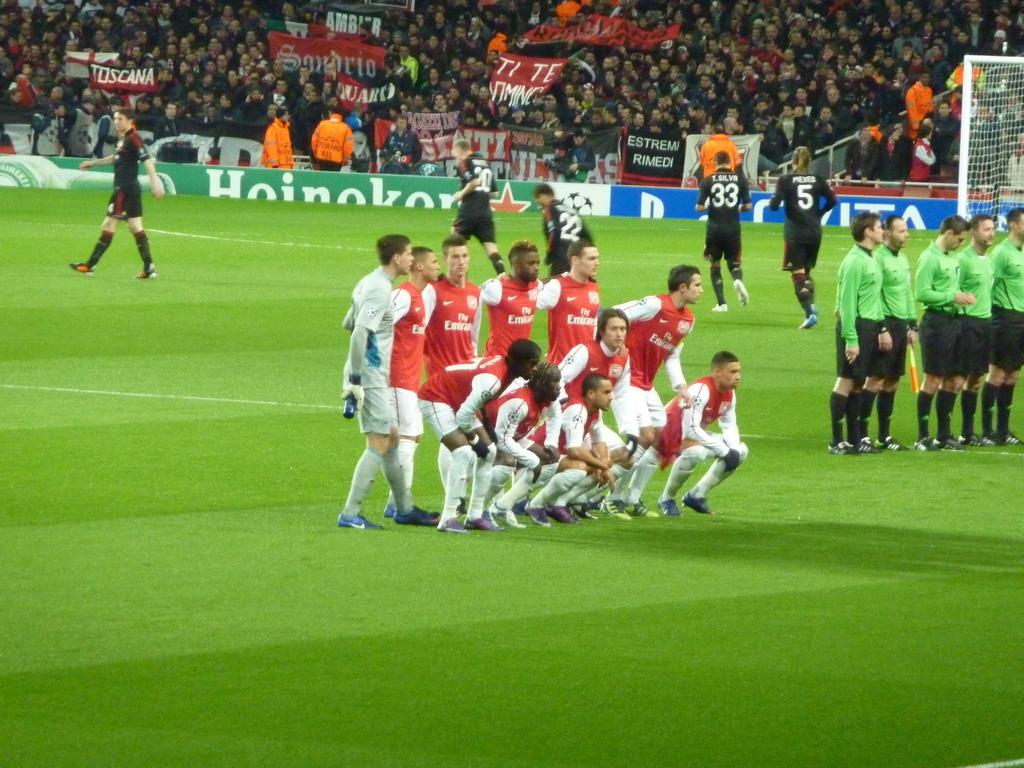Provide a one-sentence caption for the provided image. Soccer players on a field sponsored by Heinekin. 